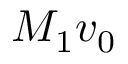Convert formula to latex. <formula><loc_0><loc_0><loc_500><loc_500>M _ { 1 } v _ { 0 }</formula> 